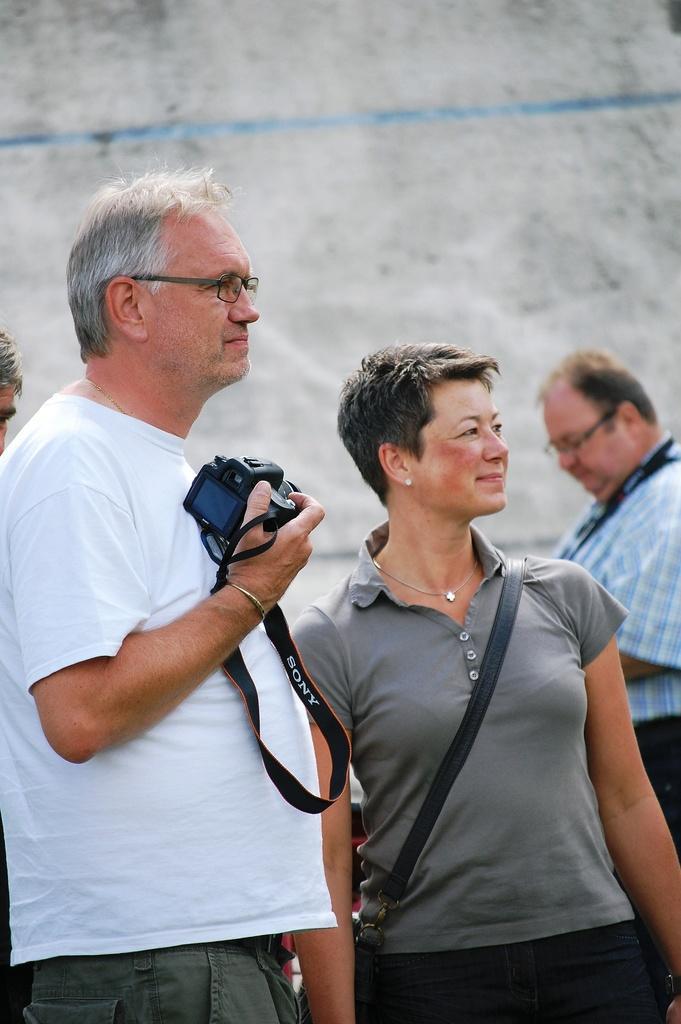Describe this image in one or two sentences. this picture shows four people and we see a man holding a camera in his hand and we see a woman she wore a handbag 